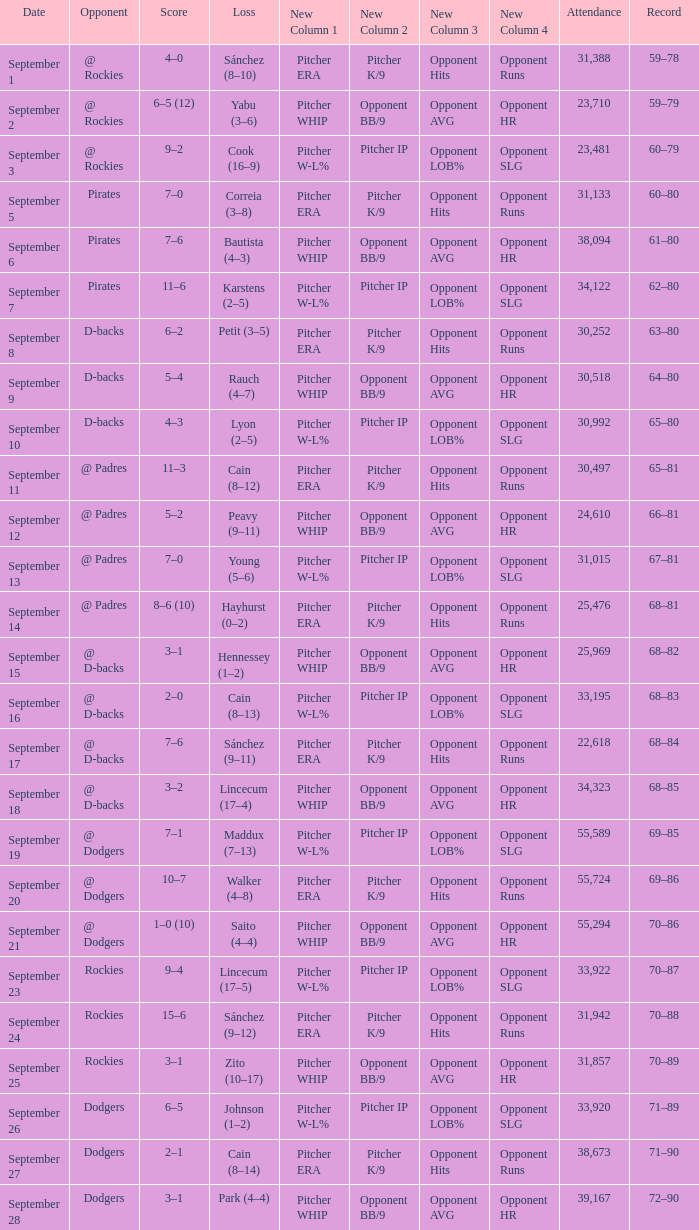What was the attendance on September 28? 39167.0. 